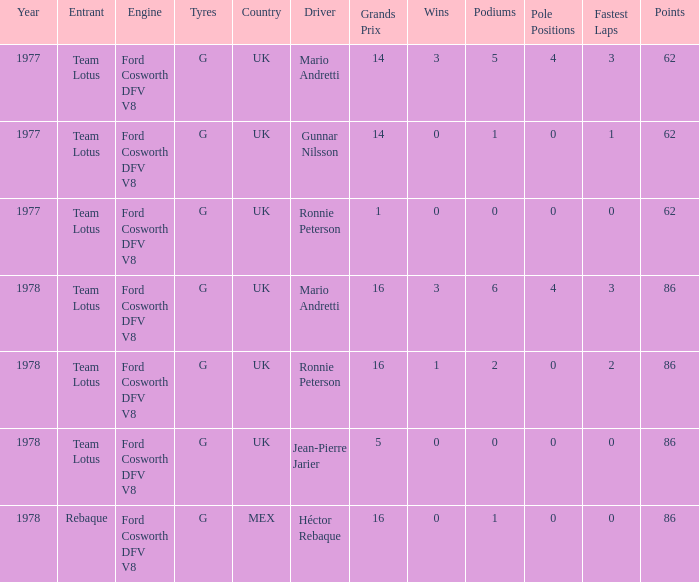What is the Motor that has a Focuses bigger than 62, and a Participant of rebaque? Ford Cosworth DFV V8. 